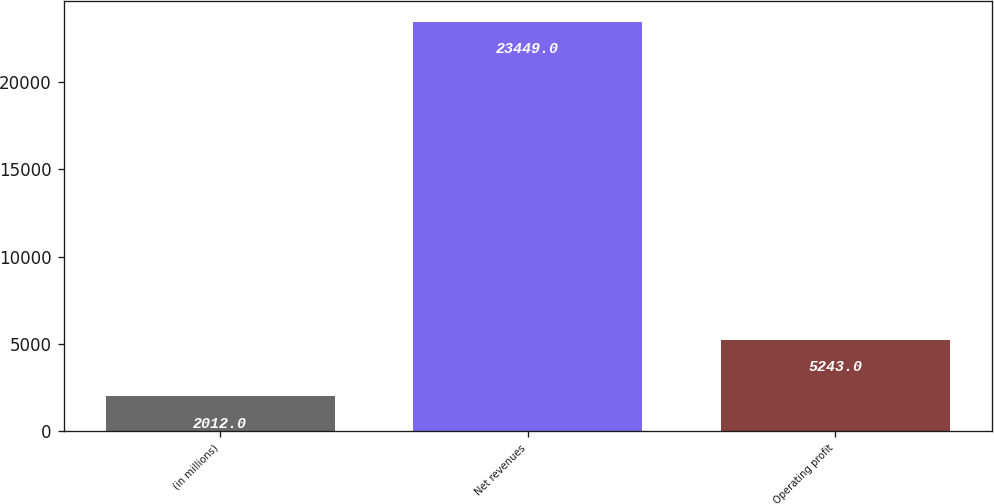<chart> <loc_0><loc_0><loc_500><loc_500><bar_chart><fcel>(in millions)<fcel>Net revenues<fcel>Operating profit<nl><fcel>2012<fcel>23449<fcel>5243<nl></chart> 